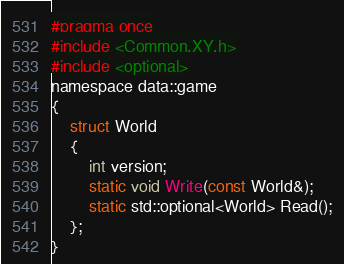Convert code to text. <code><loc_0><loc_0><loc_500><loc_500><_C_>#pragma once
#include <Common.XY.h>
#include <optional>
namespace data::game
{
	struct World
	{
		int version;
		static void Write(const World&);
		static std::optional<World> Read();
	};
}</code> 